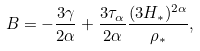Convert formula to latex. <formula><loc_0><loc_0><loc_500><loc_500>B = - \frac { 3 \gamma } { 2 \alpha } + \frac { 3 \tau _ { \alpha } } { 2 \alpha } \frac { ( 3 H _ { * } ) ^ { 2 \alpha } } { \rho _ { * } } ,</formula> 